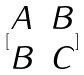Convert formula to latex. <formula><loc_0><loc_0><loc_500><loc_500>[ \begin{matrix} A & B \\ B & C \\ \end{matrix} ]</formula> 